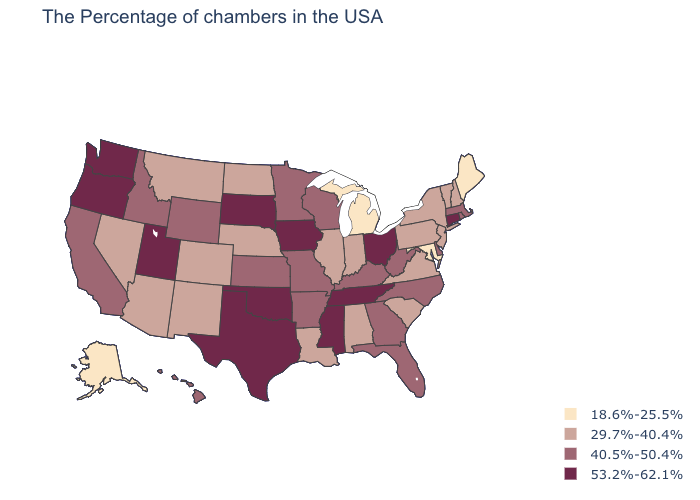Which states have the highest value in the USA?
Write a very short answer. Connecticut, Ohio, Tennessee, Mississippi, Iowa, Oklahoma, Texas, South Dakota, Utah, Washington, Oregon. Name the states that have a value in the range 29.7%-40.4%?
Answer briefly. New Hampshire, Vermont, New York, New Jersey, Pennsylvania, Virginia, South Carolina, Indiana, Alabama, Illinois, Louisiana, Nebraska, North Dakota, Colorado, New Mexico, Montana, Arizona, Nevada. Does the first symbol in the legend represent the smallest category?
Give a very brief answer. Yes. Among the states that border Kansas , which have the lowest value?
Concise answer only. Nebraska, Colorado. Which states have the highest value in the USA?
Give a very brief answer. Connecticut, Ohio, Tennessee, Mississippi, Iowa, Oklahoma, Texas, South Dakota, Utah, Washington, Oregon. Does Kentucky have the highest value in the USA?
Give a very brief answer. No. Name the states that have a value in the range 29.7%-40.4%?
Keep it brief. New Hampshire, Vermont, New York, New Jersey, Pennsylvania, Virginia, South Carolina, Indiana, Alabama, Illinois, Louisiana, Nebraska, North Dakota, Colorado, New Mexico, Montana, Arizona, Nevada. Which states have the lowest value in the South?
Keep it brief. Maryland. What is the value of Delaware?
Answer briefly. 40.5%-50.4%. Among the states that border Mississippi , does Tennessee have the lowest value?
Give a very brief answer. No. Name the states that have a value in the range 18.6%-25.5%?
Short answer required. Maine, Maryland, Michigan, Alaska. Does Illinois have the highest value in the USA?
Write a very short answer. No. Name the states that have a value in the range 40.5%-50.4%?
Quick response, please. Massachusetts, Rhode Island, Delaware, North Carolina, West Virginia, Florida, Georgia, Kentucky, Wisconsin, Missouri, Arkansas, Minnesota, Kansas, Wyoming, Idaho, California, Hawaii. Does the map have missing data?
Keep it brief. No. 